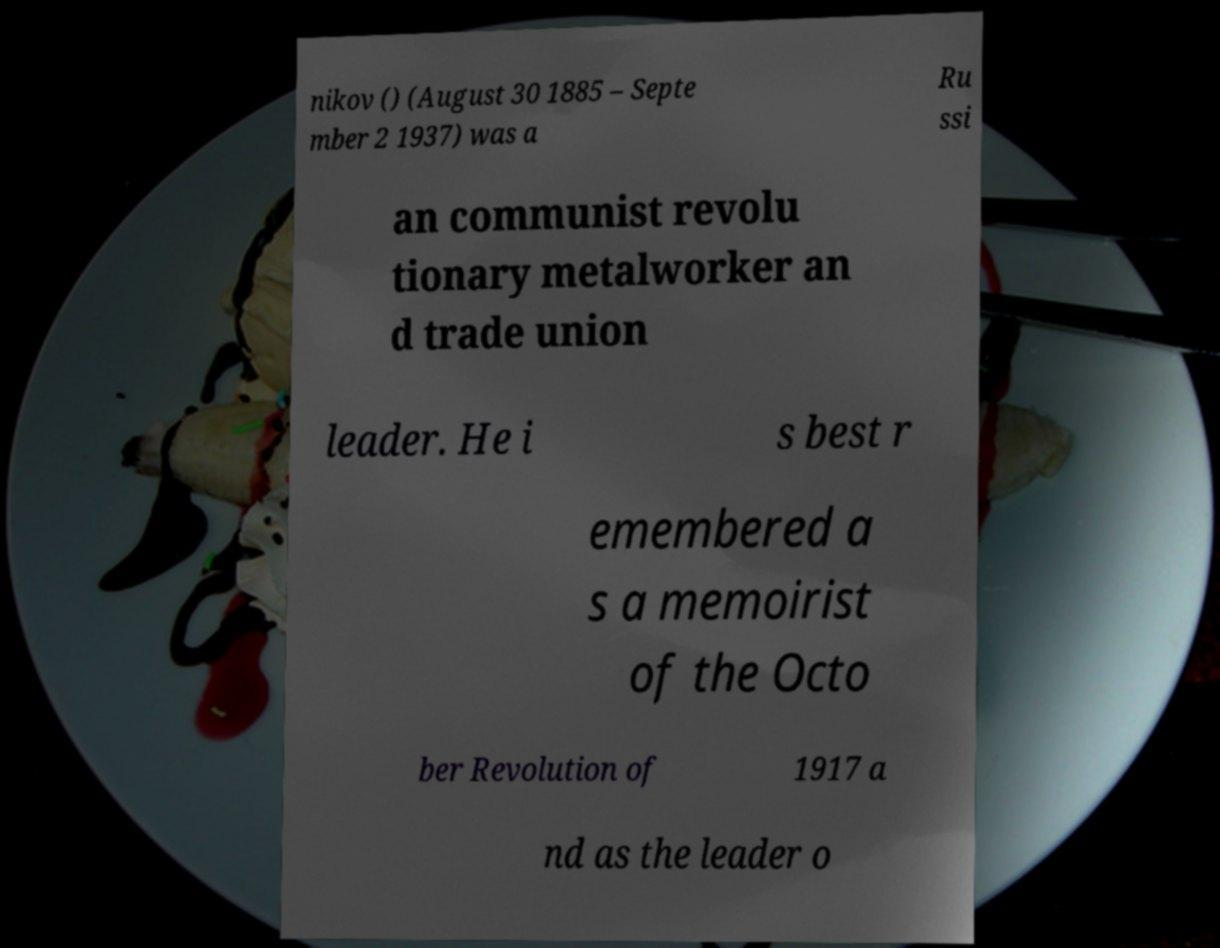Please read and relay the text visible in this image. What does it say? nikov () (August 30 1885 – Septe mber 2 1937) was a Ru ssi an communist revolu tionary metalworker an d trade union leader. He i s best r emembered a s a memoirist of the Octo ber Revolution of 1917 a nd as the leader o 